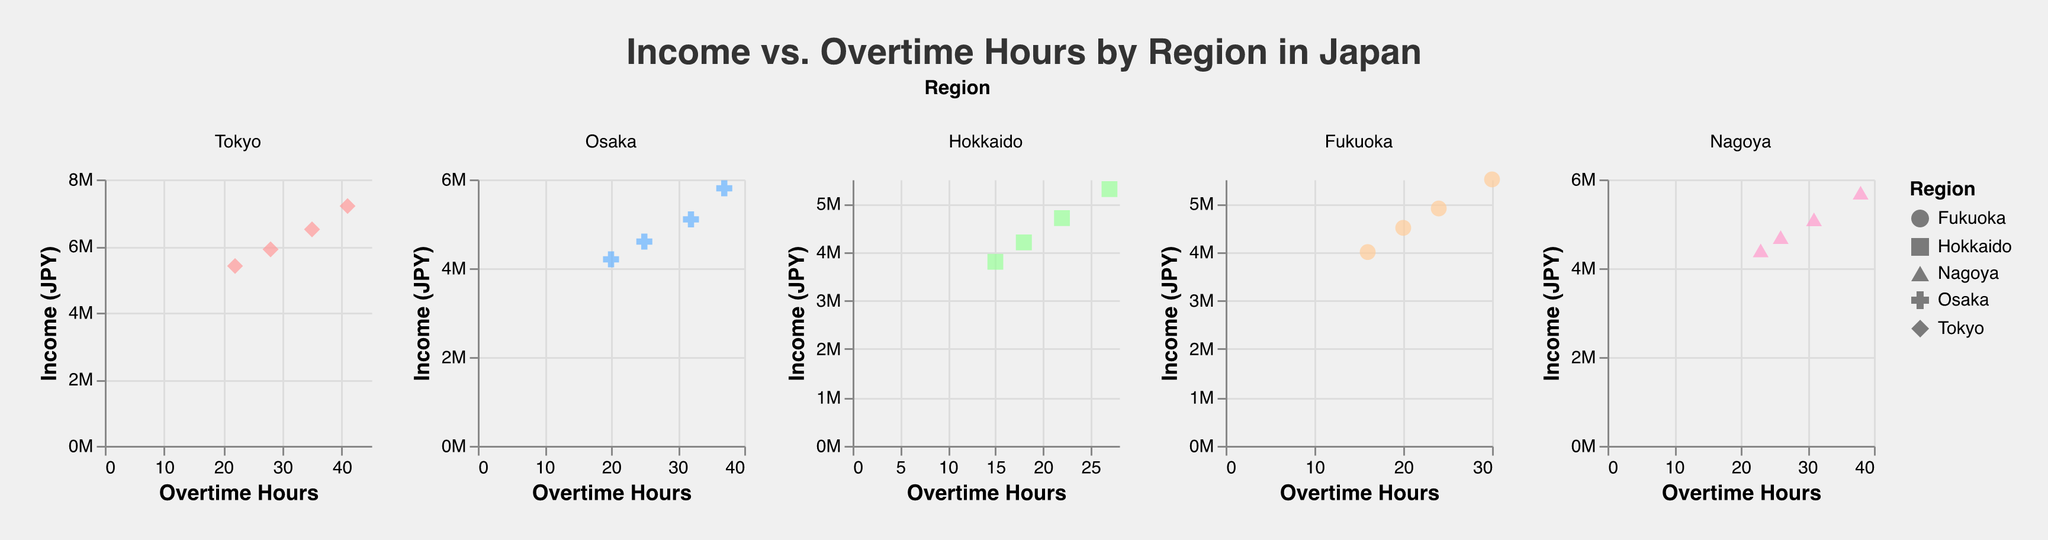What's the title of the figure? The title is clearly visible at the top of the figure.
Answer: Income vs. Overtime Hours by Region in Japan How many data points are there for the Osaka region? In the subplot for Osaka, we see four points, each corresponding to a data observation.
Answer: 4 Which region has the highest income, and what is it? By looking at the highest point across all subplots, we can see that the maximum income point is in the Tokyo subplot.
Answer: Tokyo, 7200000 JPY What is the average overtime hours for Hokkaido? Add up all the overtime hours of the data points in the Hokkaido subplot (15 + 18 + 22 + 27) and divide by the number of data points (4).
Answer: 20.5 hours Compare the overtime hours between the highest income points in Tokyo and Osaka. Which is higher? Identify the highest income point in each region's subplot. For Tokyo: 41 hours at 7200000 JPY, and for Osaka: 37 hours at 5800000 JPY.
Answer: Tokyo, 41 hours In which region does the overtime hours increase linearly with income? Observing each subplot, we can see that in Nagoya, the relationship between overtime hours and income appears to be close to linear.
Answer: Nagoya What's the difference in income between the highest and lowest data points in Fukuoka? In the Fukuoka subplot, the highest income is 5500000 JPY and the lowest is 4000000 JPY. The difference is 5500000 - 4000000.
Answer: 1500000 JPY Identify the region with the least variation in overtime hours. By comparing the range of overtime hours in each subplot, Hokkaido has the smallest range (15 to 27 hours).
Answer: Hokkaido Which region has the data point with the lowest overtime hours? Across all subplots, the lowest overtime hours data point is in Hokkaido with 15 hours.
Answer: Hokkaido 